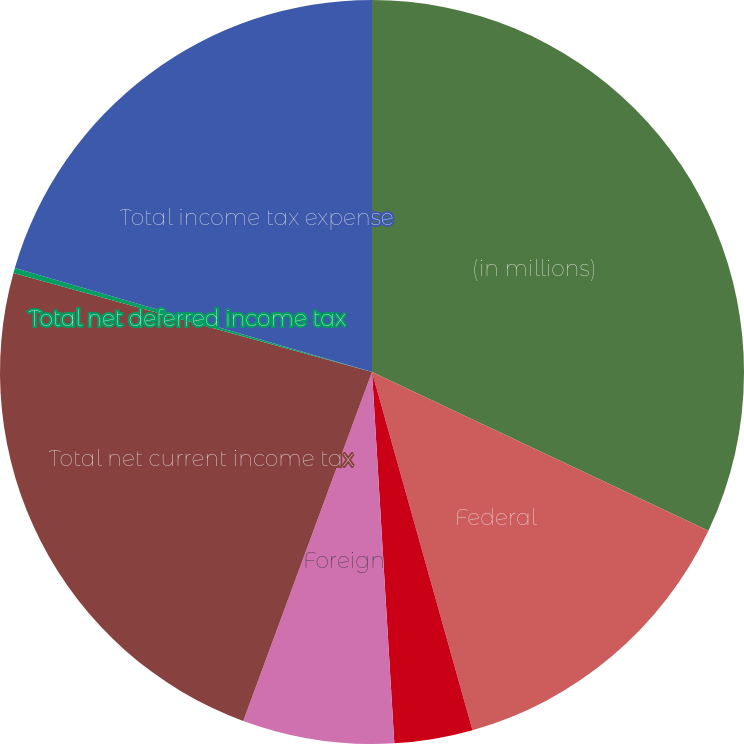Convert chart. <chart><loc_0><loc_0><loc_500><loc_500><pie_chart><fcel>(in millions)<fcel>Federal<fcel>State and local<fcel>Foreign<fcel>Total net current income tax<fcel>Total net deferred income tax<fcel>Total income tax expense<nl><fcel>32.02%<fcel>13.63%<fcel>3.4%<fcel>6.58%<fcel>23.67%<fcel>0.22%<fcel>20.49%<nl></chart> 